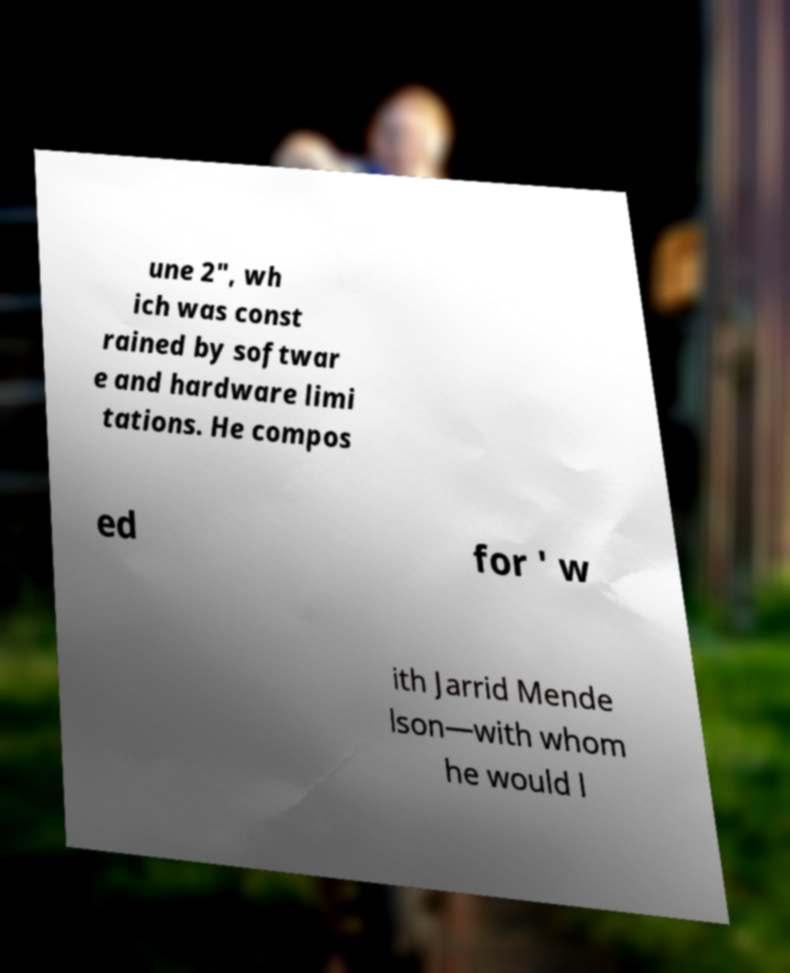There's text embedded in this image that I need extracted. Can you transcribe it verbatim? une 2", wh ich was const rained by softwar e and hardware limi tations. He compos ed for ' w ith Jarrid Mende lson—with whom he would l 